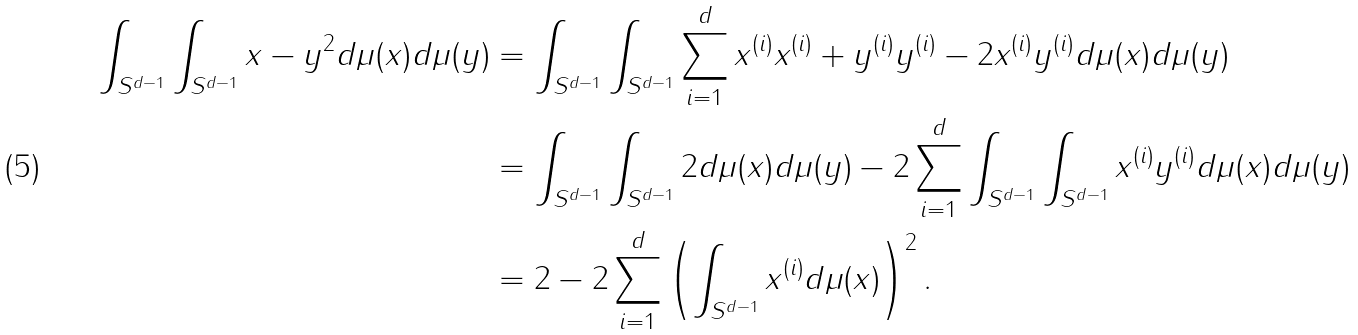<formula> <loc_0><loc_0><loc_500><loc_500>\int _ { S ^ { d - 1 } } \int _ { S ^ { d - 1 } } \| x - y \| ^ { 2 } d \mu ( x ) d \mu ( y ) & = \int _ { S ^ { d - 1 } } \int _ { S ^ { d - 1 } } \sum _ { i = 1 } ^ { d } x ^ { ( i ) } x ^ { ( i ) } + y ^ { ( i ) } y ^ { ( i ) } - 2 x ^ { ( i ) } y ^ { ( i ) } d \mu ( x ) d \mu ( y ) \\ & = \int _ { S ^ { d - 1 } } \int _ { S ^ { d - 1 } } 2 d \mu ( x ) d \mu ( y ) - 2 \sum _ { i = 1 } ^ { d } \int _ { S ^ { d - 1 } } \int _ { S ^ { d - 1 } } x ^ { ( i ) } y ^ { ( i ) } d \mu ( x ) d \mu ( y ) \\ & = 2 - 2 \sum _ { i = 1 } ^ { d } \left ( \int _ { S ^ { d - 1 } } x ^ { ( i ) } d \mu ( x ) \right ) ^ { 2 } .</formula> 